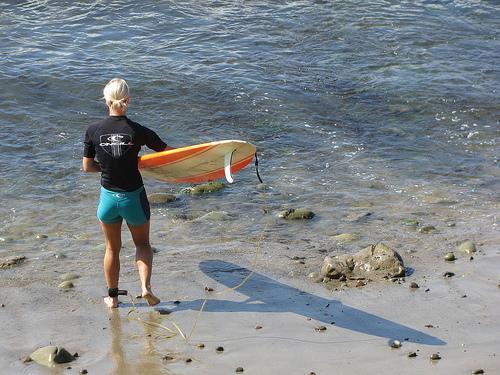How many people are going into water?
Give a very brief answer. 1. 